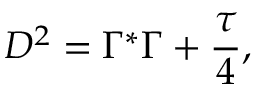<formula> <loc_0><loc_0><loc_500><loc_500>D ^ { 2 } = \Gamma ^ { * } \Gamma + { \frac { \tau } { 4 } } ,</formula> 